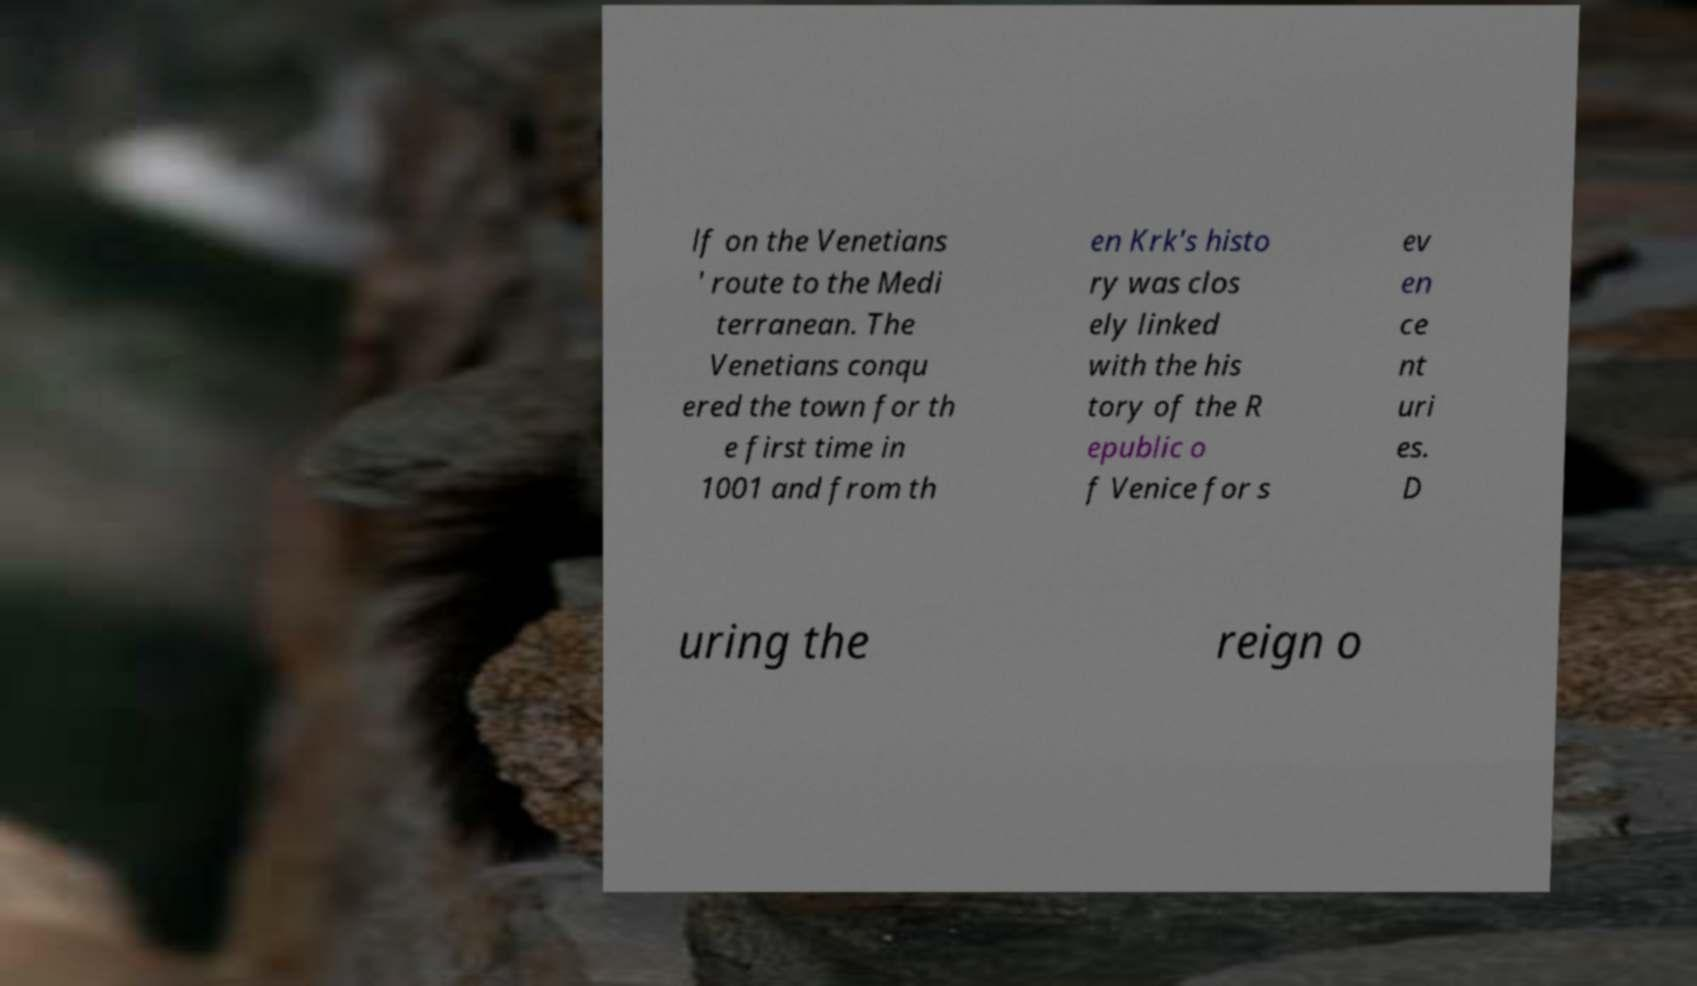Please read and relay the text visible in this image. What does it say? lf on the Venetians ' route to the Medi terranean. The Venetians conqu ered the town for th e first time in 1001 and from th en Krk's histo ry was clos ely linked with the his tory of the R epublic o f Venice for s ev en ce nt uri es. D uring the reign o 